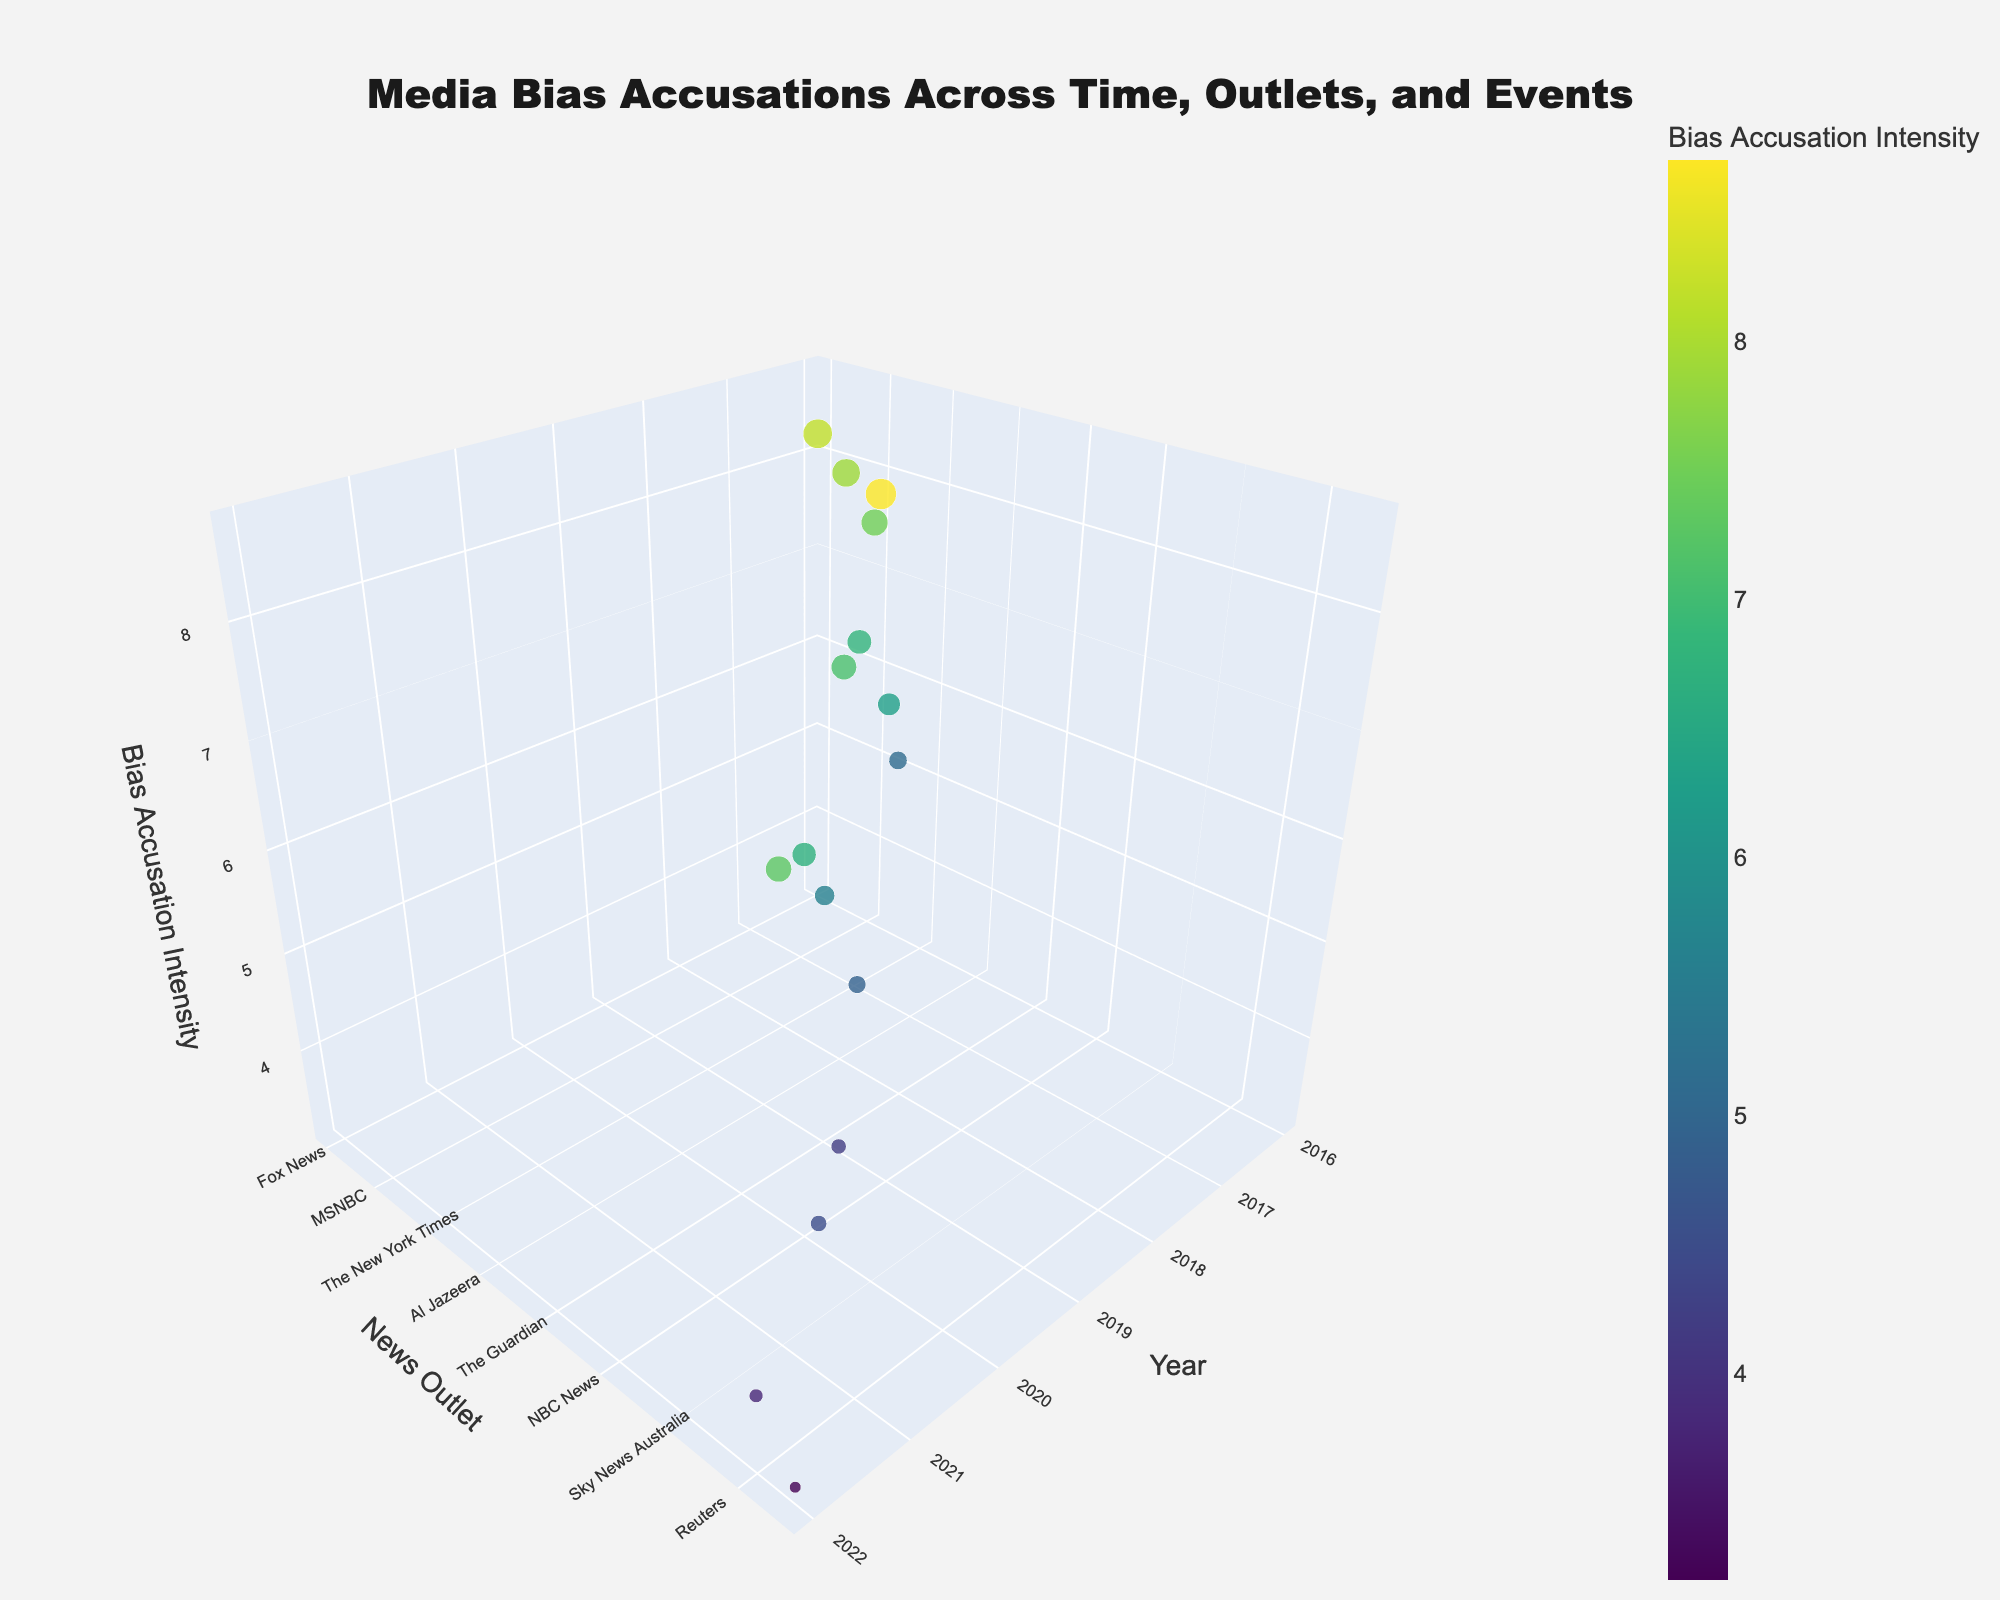What is the title of the 3D volume plot? The title of the plot can usually be found at the top of the figure and in this figure, it states what the visual is about .
Answer: Media Bias Accusations Across Time, Outlets, and Events Which news outlet has the highest bias accusation intensity in 2018? Look at the axis titled "Year" and filter for 2018. Then, check the plot markers' "News Outlet" and find the one with the highest "Bias Accusation Intensity" value for that year.
Answer: RT How many data points are on the figure? Total data points can be counted by examining the scattered markers on the plot. Each marker represents one data point.
Answer: 15 Which year has the highest overall bias accusation intensity? Identify all the markers across different years and sum up their bias accusation intensity for each year. Then compare these sums to determine which year has the highest sum.
Answer: 2016 What political event in 2021 has the lowest bias accusation intensity? Filter the plot markers by the "Year" value of 2021. Among these markers, check which "Political Event" corresponds to the smallest "Bias Accusation Intensity" value.
Answer: German Federal Election On average, how does the bias accusation intensity for political events in 2020 compare to that in 2019? Calculate the average bias accusation intensity for both 2020 and 2019 by summing their values and dividing by the number of data points for each year. Compare the two averages.
Answer: 2020 has a higher average Which news outlet witnessed the least bias accusation intensity overall? Compare the "Bias Accusation Intensity" values across all markers to find the lowest value and then check the associated "News Outlet".
Answer: Associated Press How does the bias accusation intensity of the Brexit Referendum in 2016 compare to the US Presidential Election in the same year? Filter the 2016 markers by their "Political Event" and compare the intensity associated with Brexit Referendum and US Presidential Election.
Answer: US Presidential Election is higher What is the general trend in bias accusation intensity over the years? Examine the distribution of markers from 2016 to 2022 along the "Year" axis and observe if there's an increase, decrease, or constant trend in the heights of the markers over time.
Answer: Generally decreasing Is there a noticeable difference in bias accusation intensity among major news outlets like Fox News, CNN, and NBC News? Look at the markers representing Fox News, CNN, and NBC News and compare their bias accusation intensity values.
Answer: Yes, there are differences 